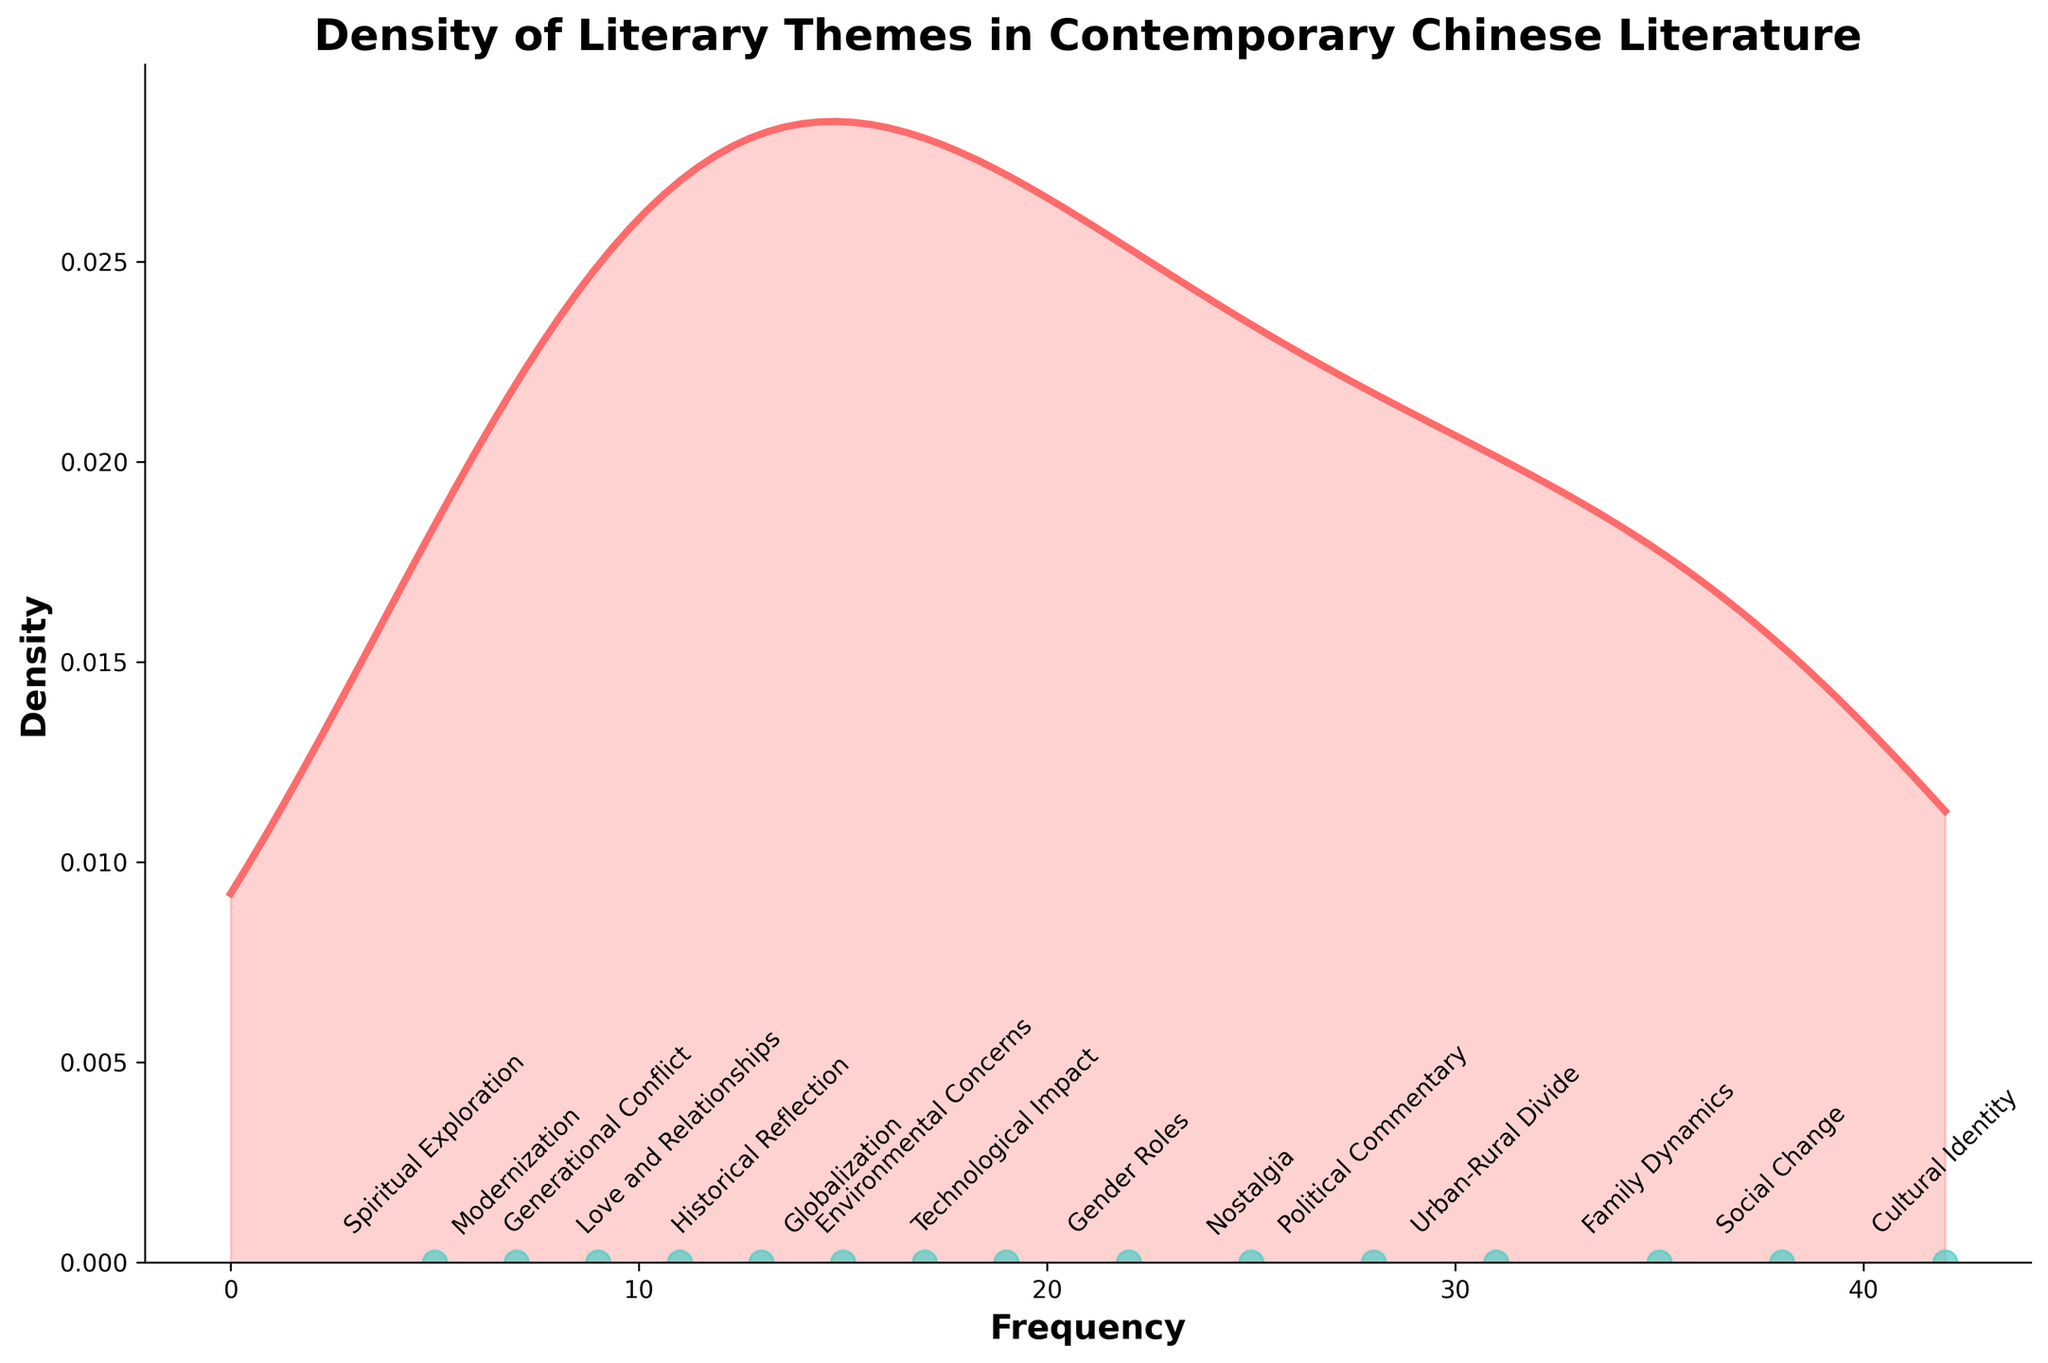What is the title of the density plot? The title is located at the top of the plot. It is typically a short sentence describing what the plot represents. In this case, it is "Density of Literary Themes in Contemporary Chinese Literature".
Answer: Density of Literary Themes in Contemporary Chinese Literature What is the maximum frequency found in the data? The frequency values are annotated along the x-axis. The highest value annotated is 42.
Answer: 42 Which theme has the lowest frequency? The themes are labeled through annotations along the x-axis where the scatter points are plotted. The theme associated with the smallest scatter point on the x-axis is "Spiritual Exploration" with a frequency of 5.
Answer: Spiritual Exploration What is the color of the scatter points representing the frequencies? The scatter points representing the frequencies are dispersed along the x-axis and are colored in a shade of green.
Answer: Green Which theme has a frequency closest to 20? By looking at the scatter points annotated along the x-axis, the theme "Technological Impact" has a frequency of 19, which is the closest to 20.
Answer: Technological Impact What is the density value at the maximum frequency? The density value corresponding to the maximum frequency of 42 can be observed from the y-axis where the density line peaks.
Answer: The density value at 42 needs to be referenced from the density line curve. This is an estimation step from the plot: around 0.04 How many themes have a frequency greater than or equal to 30? Count the number of scatter points along the x-axis with a frequency value of 30 or higher. The themes are: "Cultural Identity", "Social Change", "Family Dynamics", and "Urban-Rural Divide". That's a total of 4 themes.
Answer: 4 Which two themes have frequencies closest to each other, and what are their frequencies? From the scatter points annotated along the x-axis, compare the frequency values to identify the closest pair. The themes "Modernization" and "Generational Conflict" have frequencies of 7 and 9, respectively, which have a difference of 2.
Answer: Modernization (7) and Generational Conflict (9) Between "Cultural Identity" and "Political Commentary", which theme has a higher frequency, and by how much? By comparing the frequency values annotated at the scatter points, "Cultural Identity" has a frequency of 42, while "Political Commentary" has a frequency of 28. The difference is 42 - 28 = 14.
Answer: Cultural Identity, by 14 